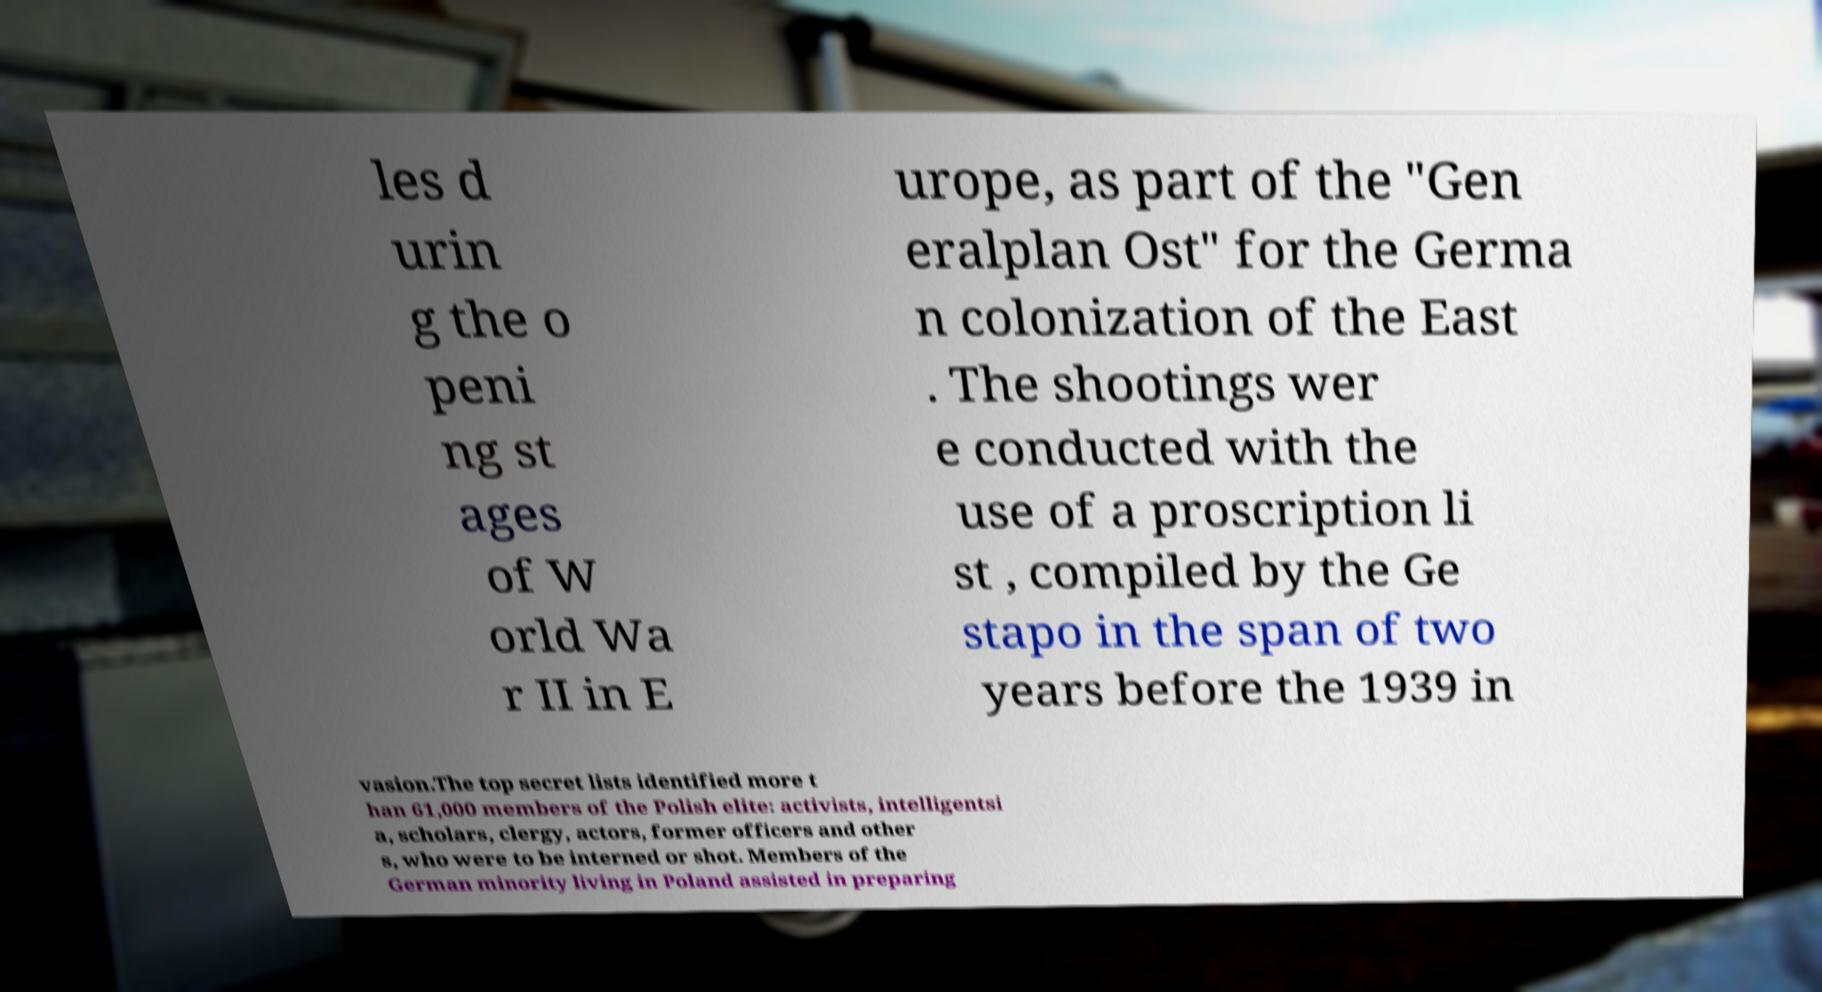Can you read and provide the text displayed in the image?This photo seems to have some interesting text. Can you extract and type it out for me? les d urin g the o peni ng st ages of W orld Wa r II in E urope, as part of the "Gen eralplan Ost" for the Germa n colonization of the East . The shootings wer e conducted with the use of a proscription li st , compiled by the Ge stapo in the span of two years before the 1939 in vasion.The top secret lists identified more t han 61,000 members of the Polish elite: activists, intelligentsi a, scholars, clergy, actors, former officers and other s, who were to be interned or shot. Members of the German minority living in Poland assisted in preparing 